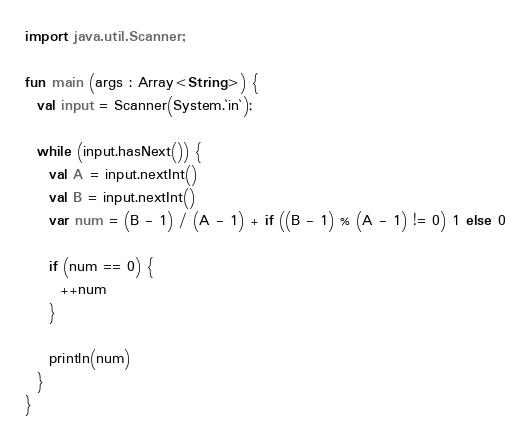Convert code to text. <code><loc_0><loc_0><loc_500><loc_500><_Kotlin_>import java.util.Scanner;

fun main (args : Array<String>) {
  val input = Scanner(System.`in`);
  
  while (input.hasNext()) {
    val A = input.nextInt()
    val B = input.nextInt()
    var num = (B - 1) / (A - 1) + if ((B - 1) % (A - 1) != 0) 1 else 0
    
    if (num == 0) {
      ++num
    }
    
    println(num)
  }
}</code> 